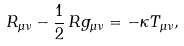<formula> <loc_0><loc_0><loc_500><loc_500>R _ { \mu \nu } - \frac { 1 } { 2 } \, R g _ { \mu \nu } = - \kappa T _ { \mu \nu } ,</formula> 